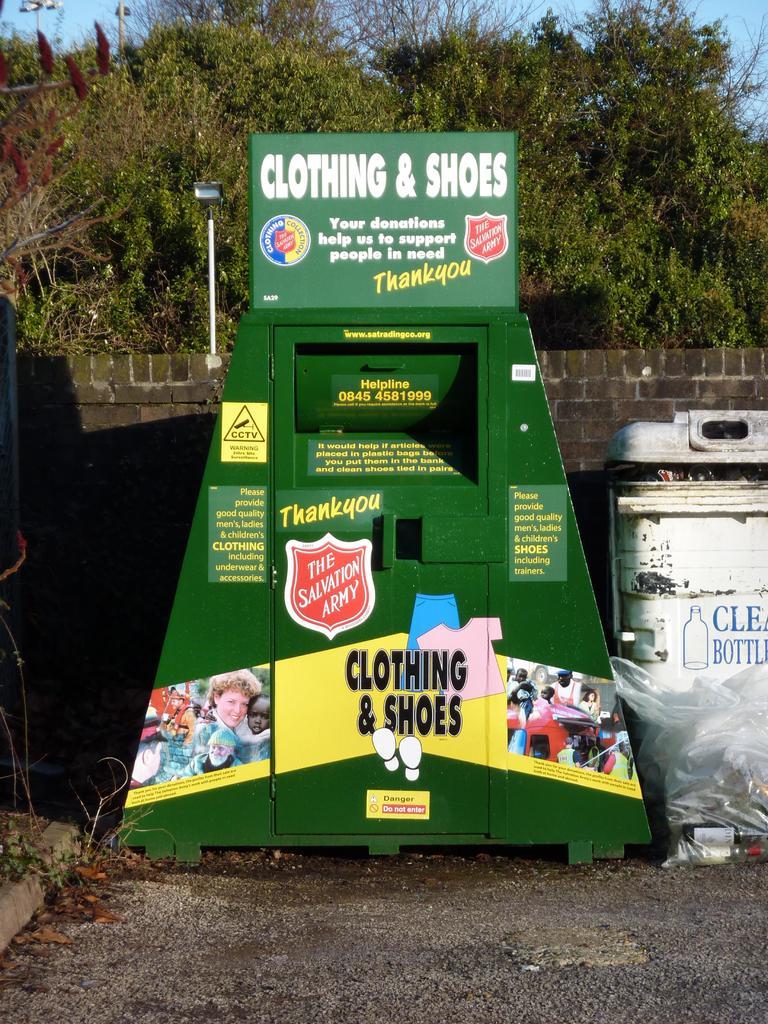What do you donate here?
Offer a terse response. Clothing & shoes. Who do you donate to?
Provide a succinct answer. The salvation army. 